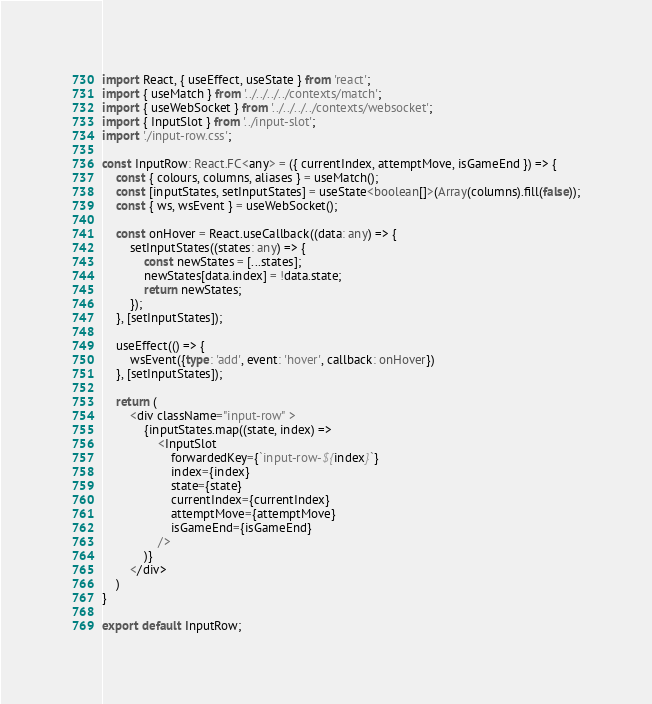Convert code to text. <code><loc_0><loc_0><loc_500><loc_500><_TypeScript_>import React, { useEffect, useState } from 'react';
import { useMatch } from '../../../../contexts/match';
import { useWebSocket } from '../../../../contexts/websocket';
import { InputSlot } from '../input-slot';
import './input-row.css';

const InputRow: React.FC<any> = ({ currentIndex, attemptMove, isGameEnd }) => {
    const { colours, columns, aliases } = useMatch();
    const [inputStates, setInputStates] = useState<boolean[]>(Array(columns).fill(false));
    const { ws, wsEvent } = useWebSocket();

    const onHover = React.useCallback((data: any) => {
        setInputStates((states: any) => {
            const newStates = [...states];
            newStates[data.index] = !data.state;
            return newStates;
        });
    }, [setInputStates]);

    useEffect(() => {
        wsEvent({type: 'add', event: 'hover', callback: onHover})
    }, [setInputStates]);

    return (
        <div className="input-row" >
            {inputStates.map((state, index) =>
                <InputSlot
                    forwardedKey={`input-row-${index}`}
                    index={index}
                    state={state}
                    currentIndex={currentIndex}
                    attemptMove={attemptMove}
                    isGameEnd={isGameEnd}
                />
            )}
        </div>
    )
}

export default InputRow;</code> 